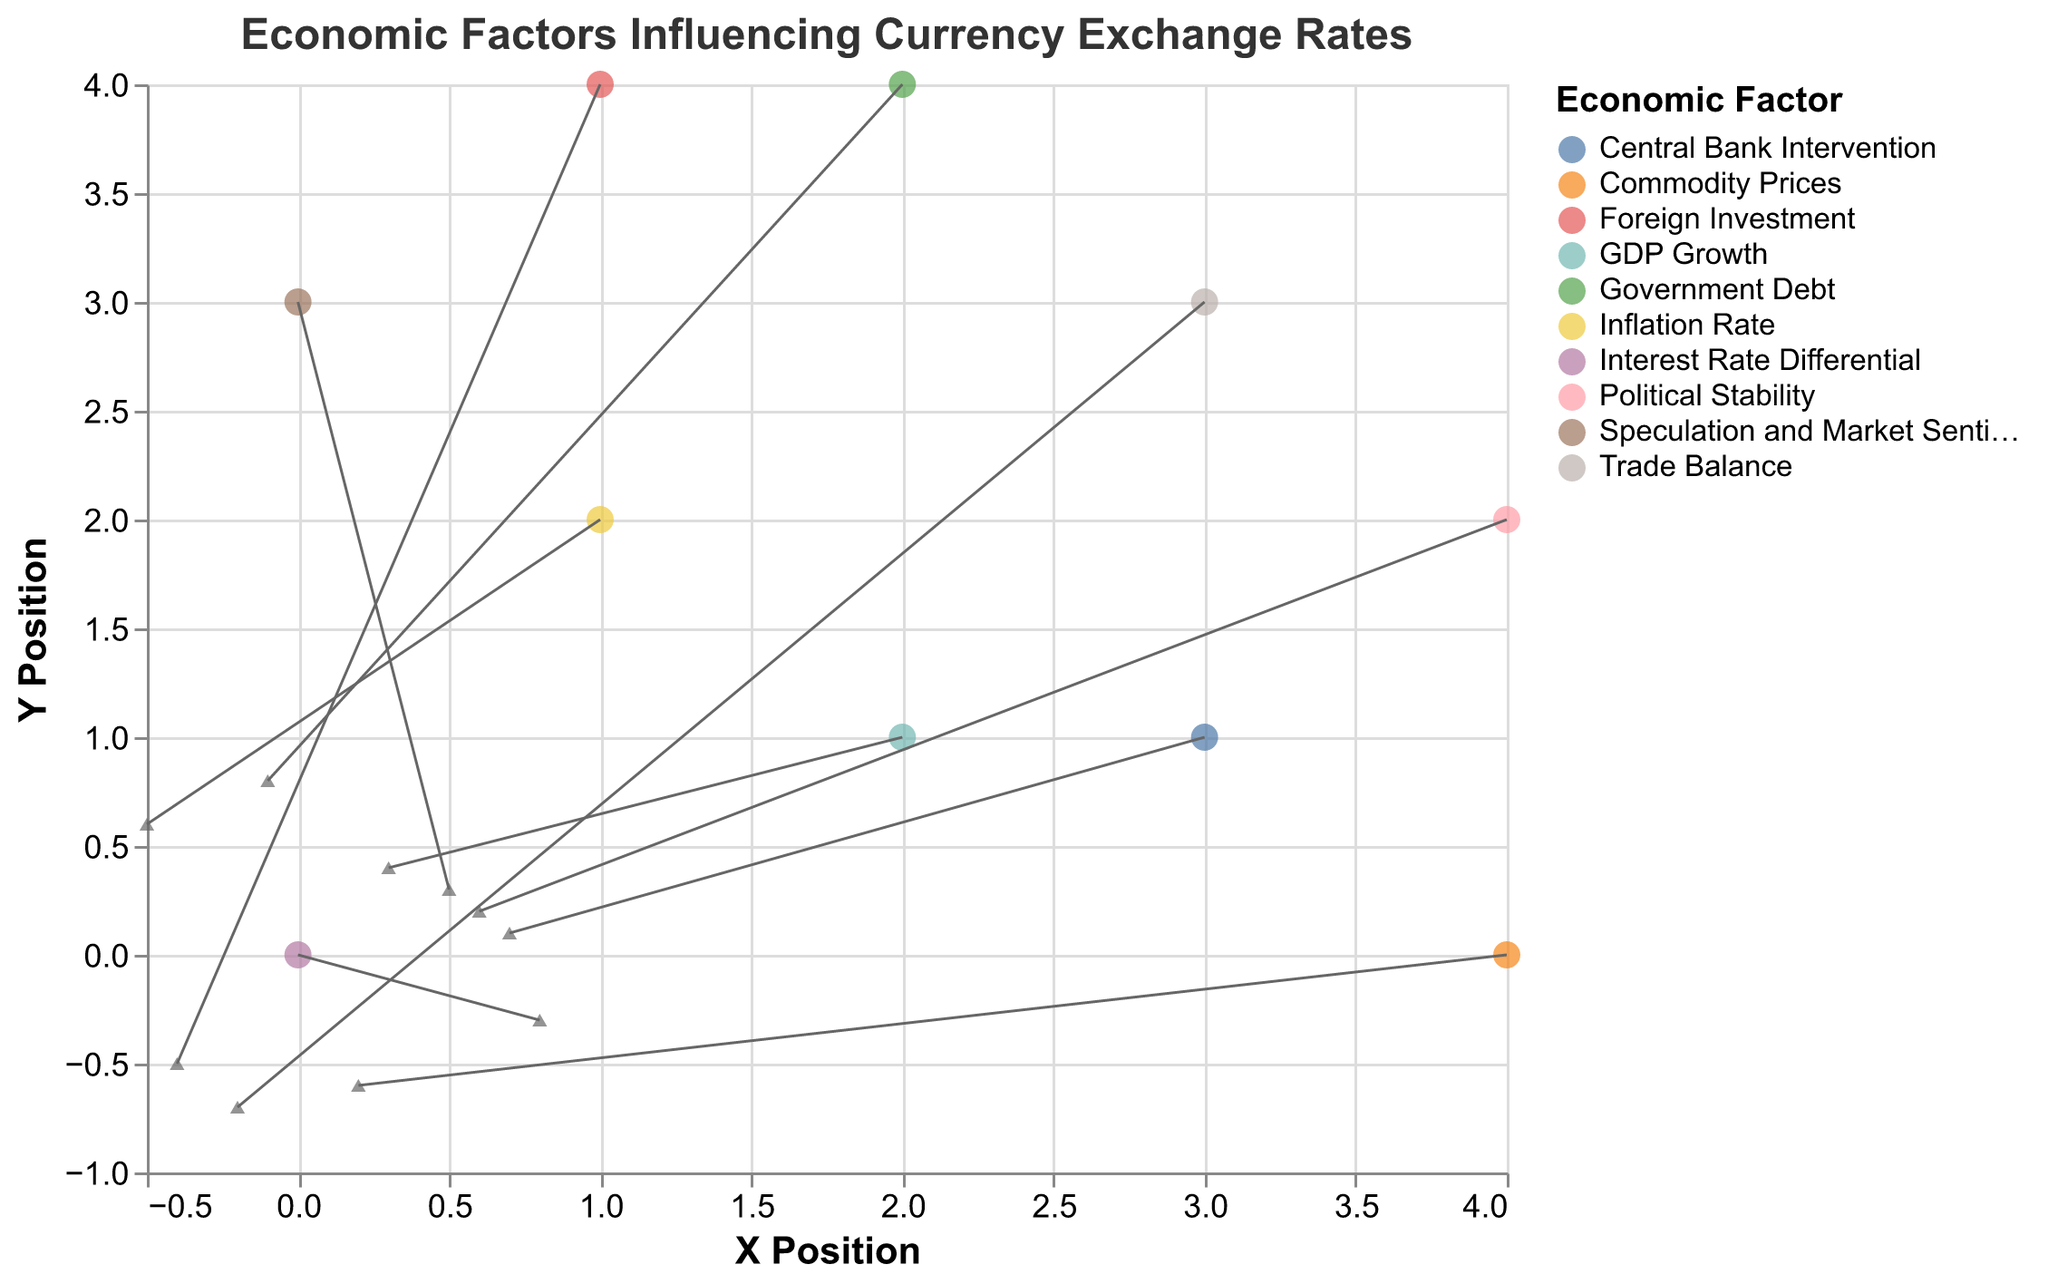What's the title of the figure? The title is visible at the top of the figure. It reads "Economic Factors Influencing Currency Exchange Rates."
Answer: Economic Factors Influencing Currency Exchange Rates What do the X and Y axes represent? The labels on the axes indicate what they represent. The X-axis represents the "X Position," and the Y-axis represents the "Y Position."
Answer: X Position and Y Position How many unique economic factors are indicated in the plot? By looking at the color legend, you can count the number of unique labels. There are 10 different economic factors.
Answer: 10 Which economic factor has the longest arrows in both horizontal and vertical directions? To find the longest arrows, compare the vector values (U, V). The "Interest Rate Differential" (U=0.8, V=-0.3) has the longest horizontal arrow, and "Government Debt" (U=-0.1, V=0.8) has the longest vertical arrow.
Answer: Interest Rate Differential (Horizontal), Government Debt (Vertical) What is the direction of the arrow for the "Inflation Rate"? The direction of the arrow is determined by the U and V components. For the "Inflation Rate" (U=-0.5, V=0.6), the arrow points to the left and slightly upward.
Answer: Left and upward Which economic factor indicates negative growth in both X and Y directions? Negative growth in both directions means both U and V are negative. "Trade Balance" (U=-0.2, V=-0.7) fits this condition.
Answer: Trade Balance Compare the vectors for "Political Stability" and "Central Bank Intervention" in terms of their length. Which one is longer? The length of the vector can be calculated with the formula √(U^2 + V^2). For "Political Stability": √(0.6^2 + 0.2^2) ≈ 0.63. For "Central Bank Intervention": √(0.7^2 + 0.1^2) ≈ 0.71. "Central Bank Intervention" is longer.
Answer: Central Bank Intervention Which factor has its arrows pointing downward? An arrow points downward if its V component is negative. The factors with negative V values are "Interest Rate Differential" and "Trade Balance."
Answer: Interest Rate Differential and Trade Balance What is the position of the "Foreign Investment" factor, and what direction does its arrow point to? The position is given by the (X, Y) coordinates, and arrow direction by (U, V). For "Foreign Investment" (X=1, Y=4, U=-0.4, V=-0.5), it is located at (1, 4) and points left and downward.
Answer: (1, 4), left and downward 